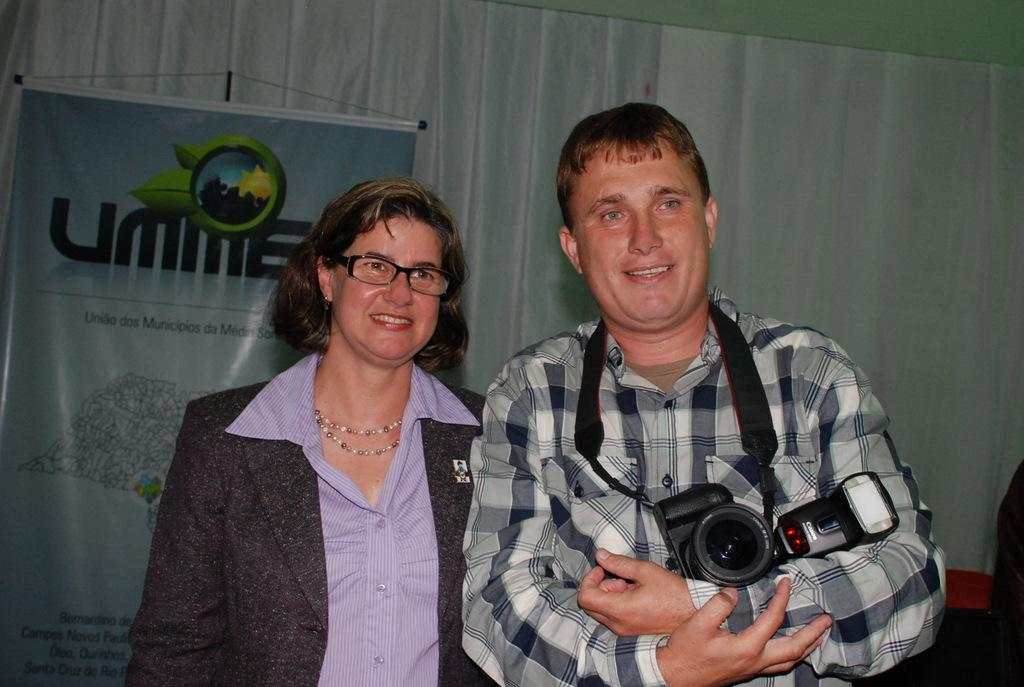What is the man in the image doing? The man is posing with a camera in the image. Who is with the man in the image? There is a woman beside the man in the image. Can you describe the woman's position in relation to the man? The woman is beside the man in the image. What type of tool is the man using as a toothpick in the image? There is no tool or toothpick present in the image; the man is posing with a camera. 